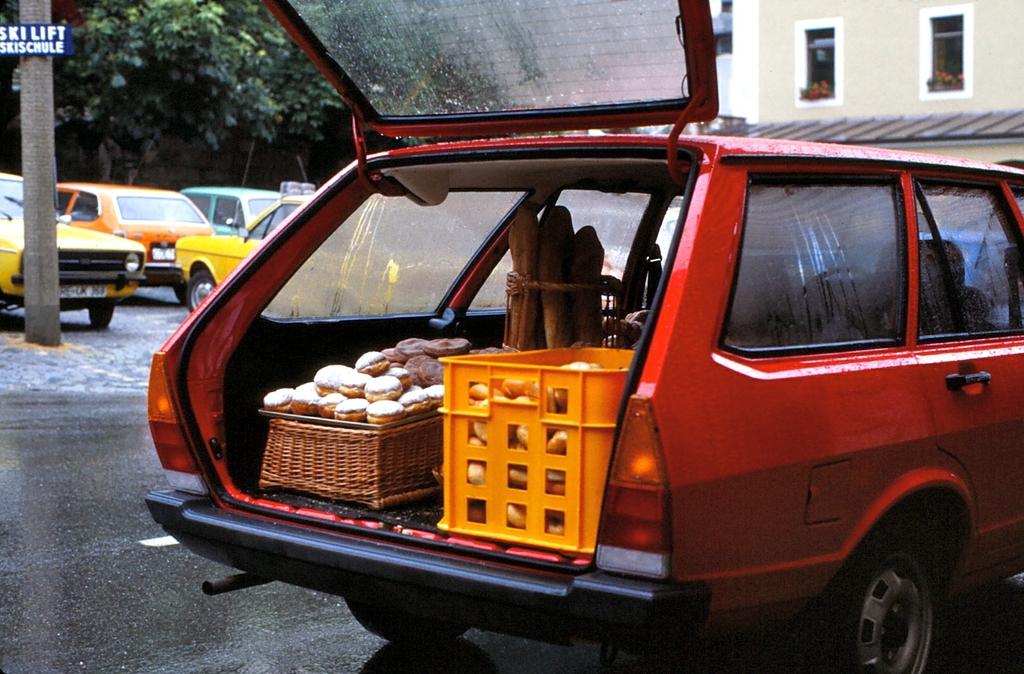What type of parking is behind the pole?
Offer a terse response. Ski lift. 